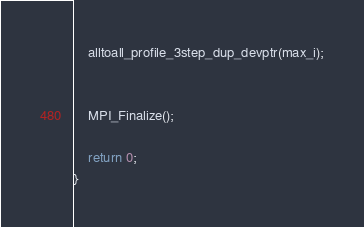<code> <loc_0><loc_0><loc_500><loc_500><_C++_>    alltoall_profile_3step_dup_devptr(max_i);


    MPI_Finalize();

    return 0;
}

</code> 